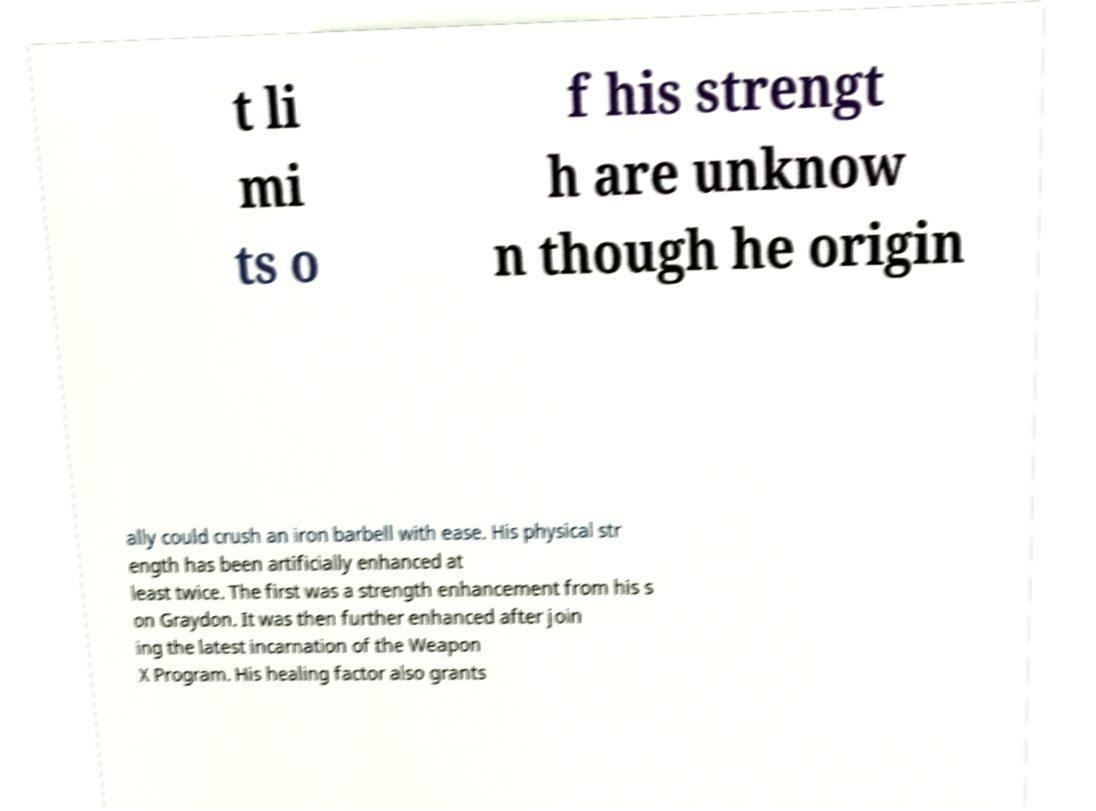For documentation purposes, I need the text within this image transcribed. Could you provide that? t li mi ts o f his strengt h are unknow n though he origin ally could crush an iron barbell with ease. His physical str ength has been artificially enhanced at least twice. The first was a strength enhancement from his s on Graydon. It was then further enhanced after join ing the latest incarnation of the Weapon X Program. His healing factor also grants 